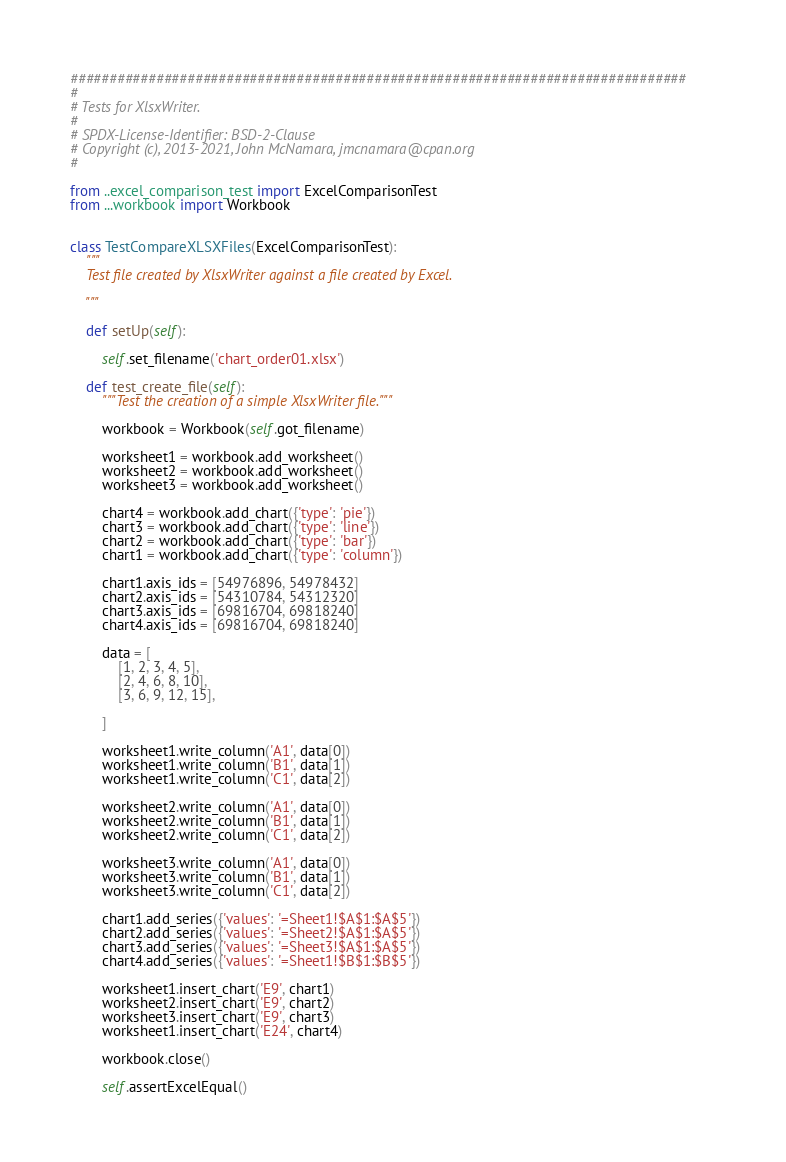<code> <loc_0><loc_0><loc_500><loc_500><_Python_>###############################################################################
#
# Tests for XlsxWriter.
#
# SPDX-License-Identifier: BSD-2-Clause
# Copyright (c), 2013-2021, John McNamara, jmcnamara@cpan.org
#

from ..excel_comparison_test import ExcelComparisonTest
from ...workbook import Workbook


class TestCompareXLSXFiles(ExcelComparisonTest):
    """
    Test file created by XlsxWriter against a file created by Excel.

    """

    def setUp(self):

        self.set_filename('chart_order01.xlsx')

    def test_create_file(self):
        """Test the creation of a simple XlsxWriter file."""

        workbook = Workbook(self.got_filename)

        worksheet1 = workbook.add_worksheet()
        worksheet2 = workbook.add_worksheet()
        worksheet3 = workbook.add_worksheet()

        chart4 = workbook.add_chart({'type': 'pie'})
        chart3 = workbook.add_chart({'type': 'line'})
        chart2 = workbook.add_chart({'type': 'bar'})
        chart1 = workbook.add_chart({'type': 'column'})

        chart1.axis_ids = [54976896, 54978432]
        chart2.axis_ids = [54310784, 54312320]
        chart3.axis_ids = [69816704, 69818240]
        chart4.axis_ids = [69816704, 69818240]

        data = [
            [1, 2, 3, 4, 5],
            [2, 4, 6, 8, 10],
            [3, 6, 9, 12, 15],

        ]

        worksheet1.write_column('A1', data[0])
        worksheet1.write_column('B1', data[1])
        worksheet1.write_column('C1', data[2])

        worksheet2.write_column('A1', data[0])
        worksheet2.write_column('B1', data[1])
        worksheet2.write_column('C1', data[2])

        worksheet3.write_column('A1', data[0])
        worksheet3.write_column('B1', data[1])
        worksheet3.write_column('C1', data[2])

        chart1.add_series({'values': '=Sheet1!$A$1:$A$5'})
        chart2.add_series({'values': '=Sheet2!$A$1:$A$5'})
        chart3.add_series({'values': '=Sheet3!$A$1:$A$5'})
        chart4.add_series({'values': '=Sheet1!$B$1:$B$5'})

        worksheet1.insert_chart('E9', chart1)
        worksheet2.insert_chart('E9', chart2)
        worksheet3.insert_chart('E9', chart3)
        worksheet1.insert_chart('E24', chart4)

        workbook.close()

        self.assertExcelEqual()
</code> 